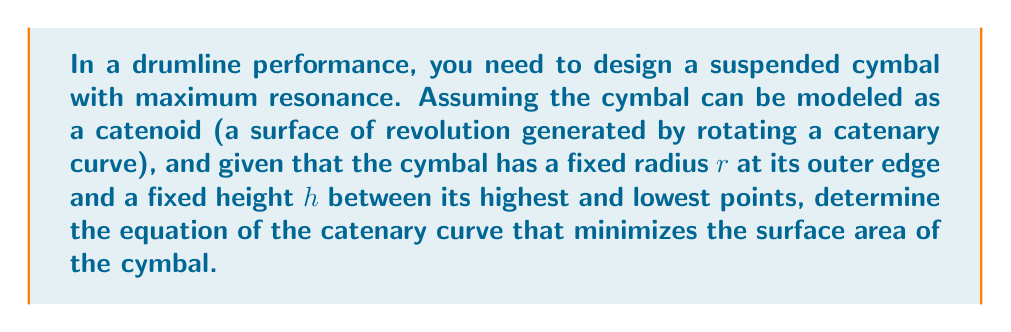Help me with this question. Let's approach this step-by-step:

1) The equation of a catenary curve is given by:

   $$y = a \cosh(\frac{x}{a})$$

   where $a$ is a constant that determines the shape of the curve.

2) For a catenoid, we rotate this curve around the y-axis. The surface area of a surface of revolution is given by:

   $$A = 2\pi \int_{0}^{h/2} y \sqrt{1 + (\frac{dy}{dx})^2} dx$$

3) Substituting the catenary equation and its derivative:

   $$A = 2\pi \int_{0}^{h/2} a \cosh(\frac{x}{a}) \sqrt{1 + \sinh^2(\frac{x}{a})} dx$$

4) This simplifies to:

   $$A = 2\pi a^2 [\sinh(\frac{x}{a})]_{0}^{h/2} = 2\pi a^2 [\sinh(\frac{h}{2a}) - 0]$$

5) We have two boundary conditions:
   - At $x = 0$, $y = r$, so $r = a \cosh(0) = a$
   - At $x = h/2$, $y = r$, so $r = a \cosh(\frac{h}{2a})$

6) From the second condition:

   $$\cosh(\frac{h}{2a}) = \frac{r}{a} = 1$$

7) This implies:

   $$\frac{h}{2a} = \text{arccosh}(1) = 0$$

8) Therefore, the minimal surface area occurs when $a$ approaches infinity, or when the catenary curve becomes a straight line.

9) In this case, the cymbal becomes a flat circular disk with radius $r$.
Answer: $y = x + r$ 